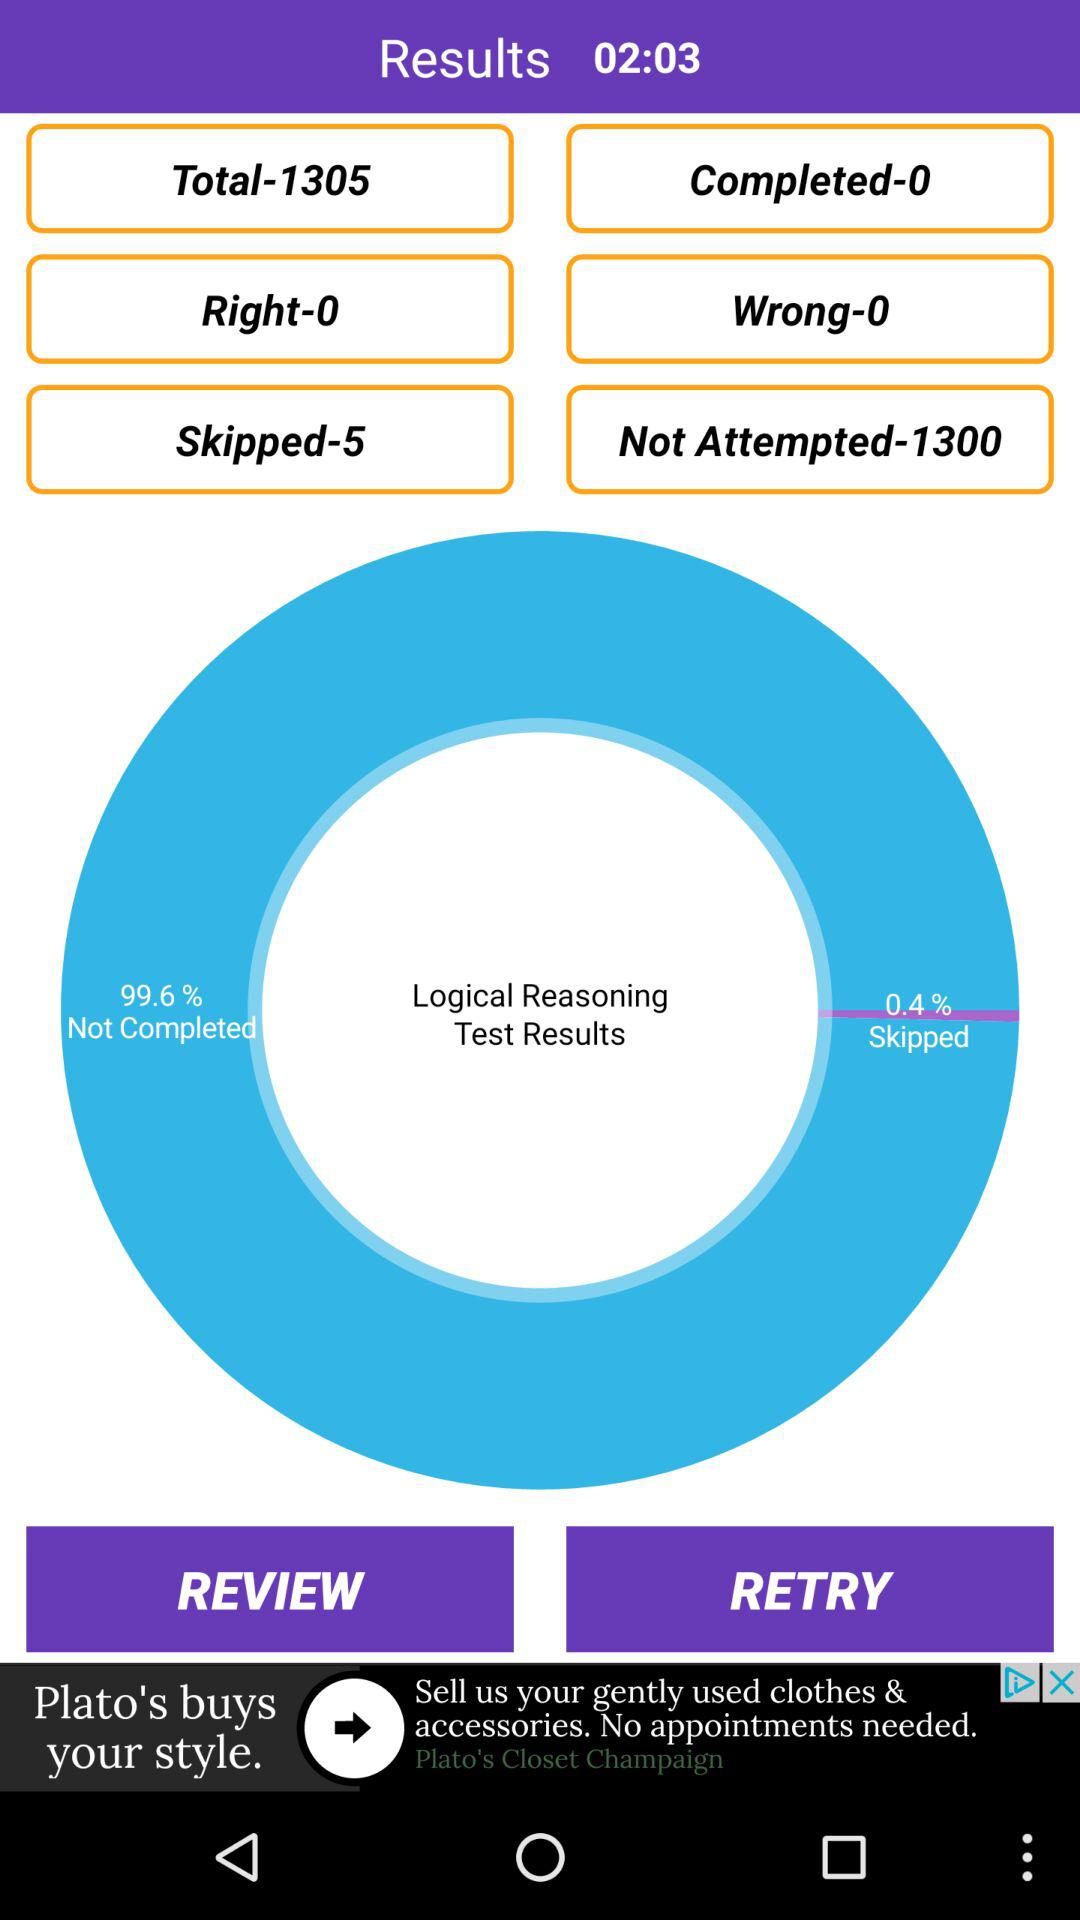What percentage of the questions were skipped?
Answer the question using a single word or phrase. 0.4% 